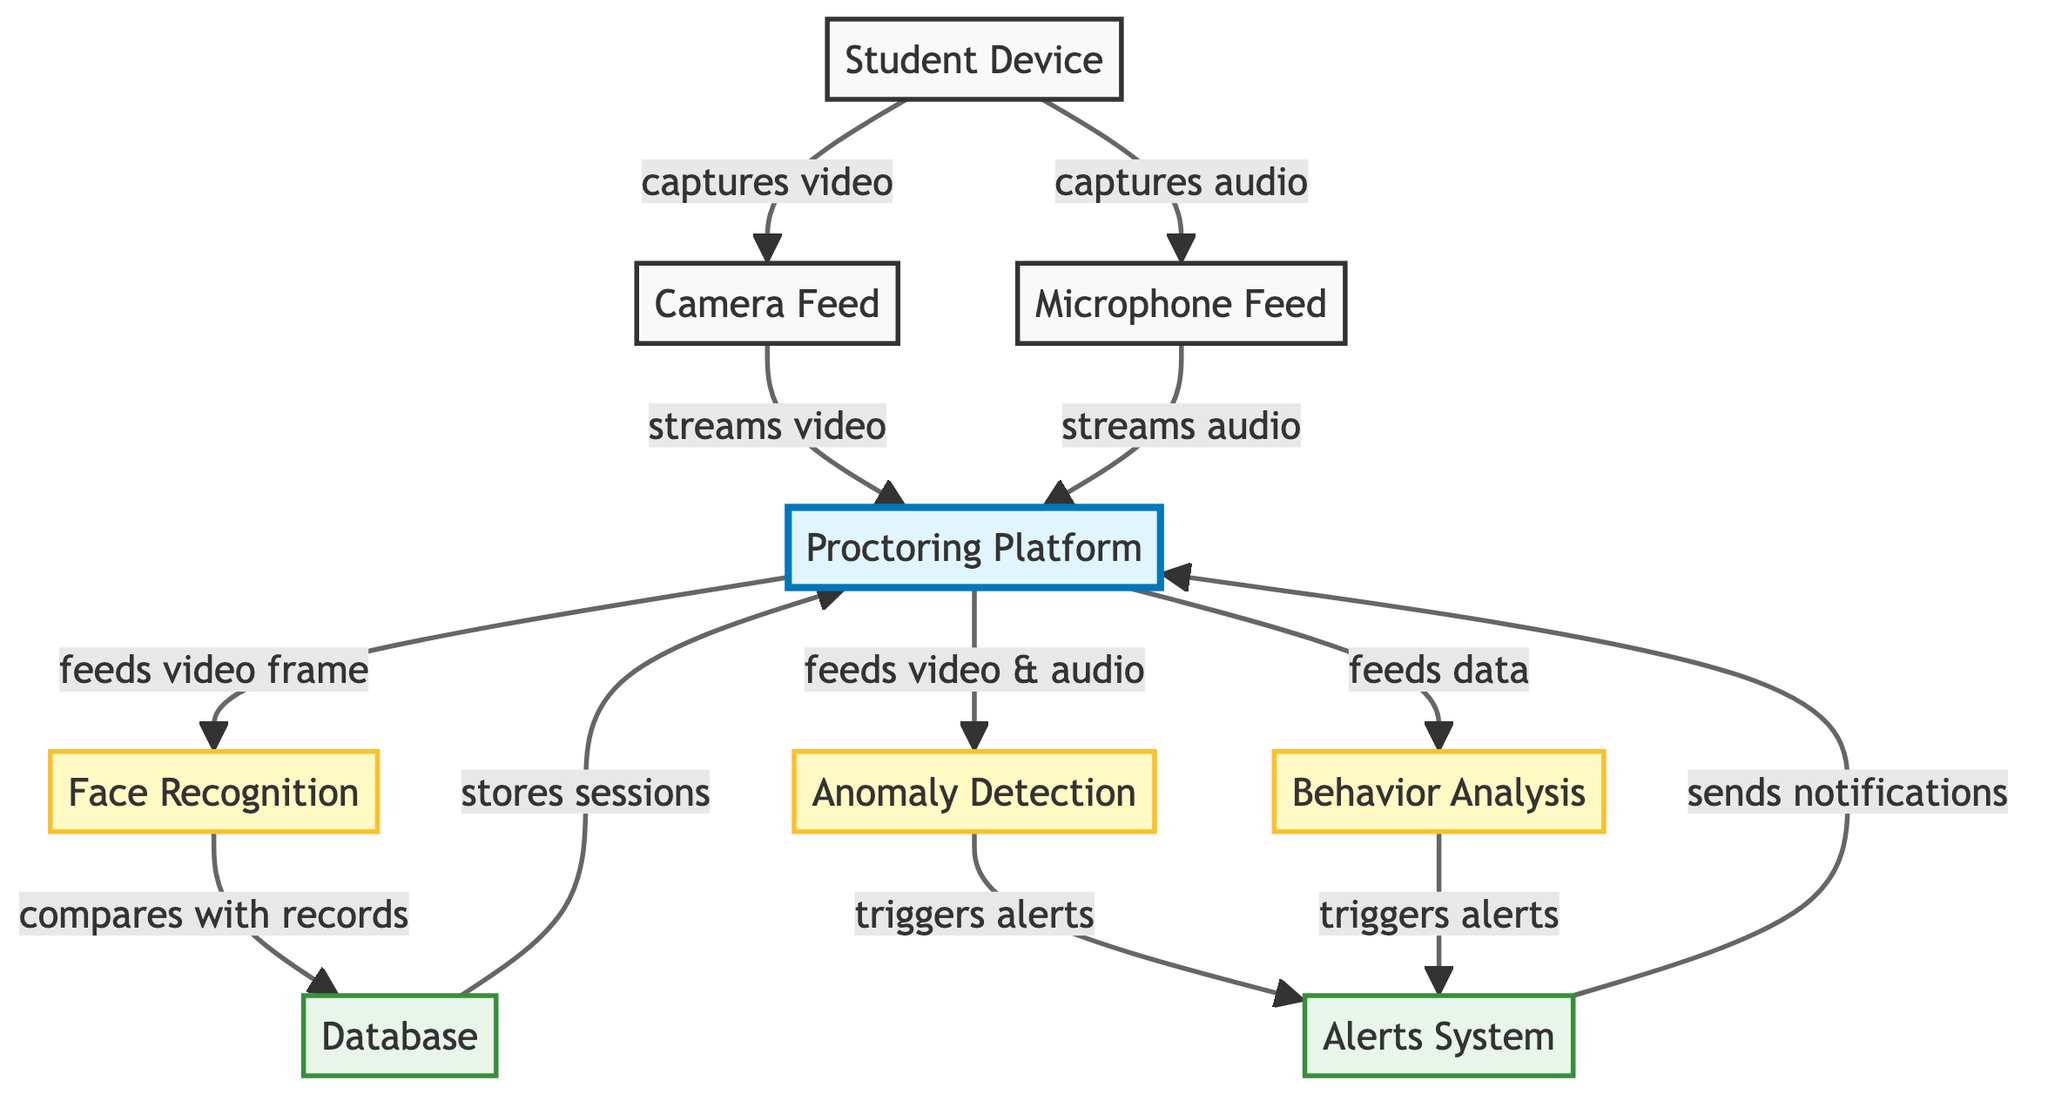What's the total number of modules in the diagram? There are three modules listed in the diagram: Face Recognition, Anomaly Detection, and Behavior Analysis.
Answer: 3 What type of resource is the "Proctoring Platform"? The "Proctoring Platform" is classified as a platform according to the color coding in the diagram.
Answer: platform What does the Camera Feed connect to? The Camera Feed connects to the Proctoring Platform, which receives the streamed video.
Answer: Proctoring Platform Which module is responsible for comparing video frames with records? The Face Recognition Module is responsible for this task, as indicated by its connection to the Database for comparison.
Answer: Face Recognition What triggers alerts in the system? Alerts are triggered by both the Anomaly Detection Module and the Behavior Analysis Module, as shown by their connections to the Alerts System.
Answer: Anomaly Detection Module, Behavior Analysis Module How does the Student Device share video with the Proctoring Platform? The Student Device captures video and then streams it through the Camera Feed to the Proctoring Platform.
Answer: Camera Feed What is the flow direction of data from the Database back to the Proctoring Platform? Data flows from the Database back to the Proctoring Platform where sessions are stored, as indicated by the arrow connecting them.
Answer: from Database to Proctoring Platform Which component sends notifications, and from which system does it receive inputs? The Alerts System sends notifications and receives input from both the Anomaly Detection Module and the Behavior Analysis Module, as indicated in the diagram.
Answer: Alerts System How many types of feeds does the Proctoring Platform receive from the Student Device? The Proctoring Platform receives two types of feeds: video (through the Camera Feed) and audio (through the Microphone Feed).
Answer: 2 